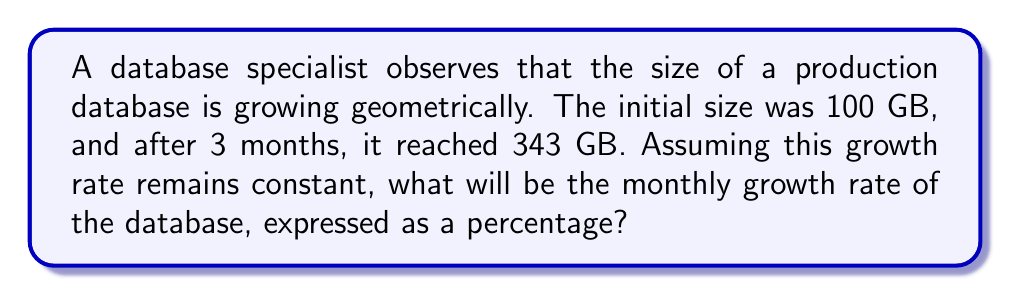Show me your answer to this math problem. Let's approach this step-by-step:

1) In a geometric sequence, each term is a constant multiple of the previous term. Let's call this constant $r$.

2) We can express the relationship between the initial and final sizes as:

   $100 \cdot r^3 = 343$

3) Solving for $r$:

   $r^3 = \frac{343}{100}$
   $r^3 = 3.43$
   $r = \sqrt[3]{3.43}$

4) Using a calculator or computer:

   $r \approx 1.5$

5) This means the database size is multiplied by 1.5 each month.

6) To convert this to a percentage growth rate, we subtract 1 and multiply by 100:

   Growth rate = $(r - 1) \cdot 100\%$
               $= (1.5 - 1) \cdot 100\%$
               $= 0.5 \cdot 100\%$
               $= 50\%$

Therefore, the monthly growth rate is 50%.
Answer: 50% 